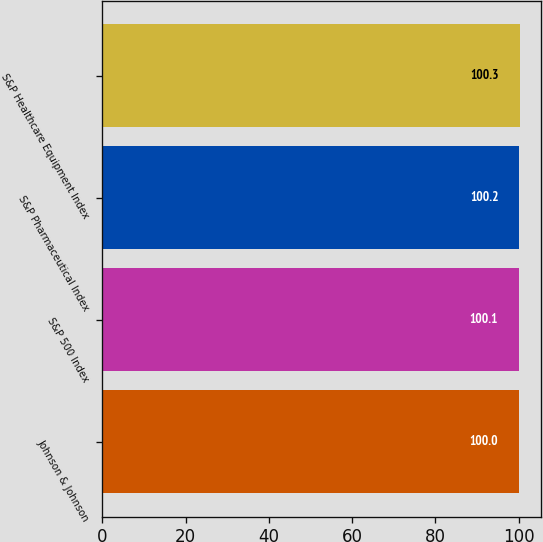<chart> <loc_0><loc_0><loc_500><loc_500><bar_chart><fcel>Johnson & Johnson<fcel>S&P 500 Index<fcel>S&P Pharmaceutical Index<fcel>S&P Healthcare Equipment Index<nl><fcel>100<fcel>100.1<fcel>100.2<fcel>100.3<nl></chart> 